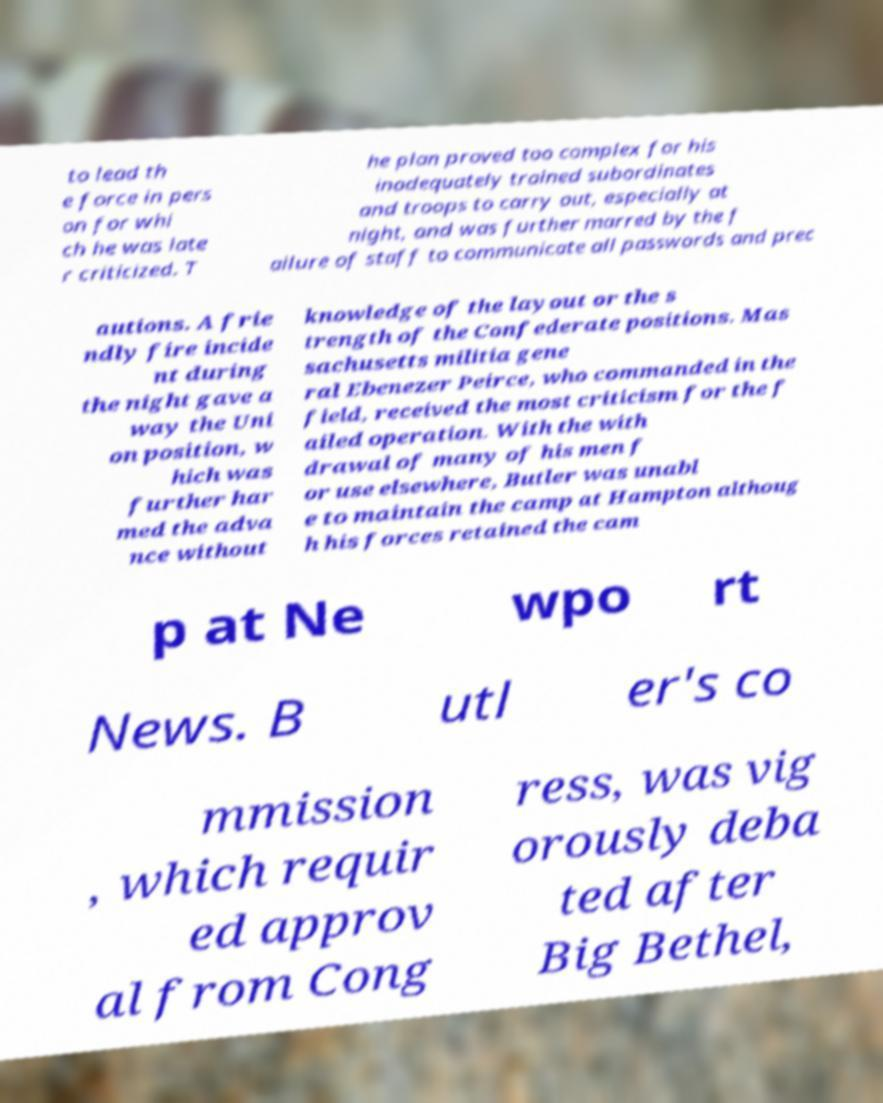There's text embedded in this image that I need extracted. Can you transcribe it verbatim? to lead th e force in pers on for whi ch he was late r criticized. T he plan proved too complex for his inadequately trained subordinates and troops to carry out, especially at night, and was further marred by the f ailure of staff to communicate all passwords and prec autions. A frie ndly fire incide nt during the night gave a way the Uni on position, w hich was further har med the adva nce without knowledge of the layout or the s trength of the Confederate positions. Mas sachusetts militia gene ral Ebenezer Peirce, who commanded in the field, received the most criticism for the f ailed operation. With the with drawal of many of his men f or use elsewhere, Butler was unabl e to maintain the camp at Hampton althoug h his forces retained the cam p at Ne wpo rt News. B utl er's co mmission , which requir ed approv al from Cong ress, was vig orously deba ted after Big Bethel, 